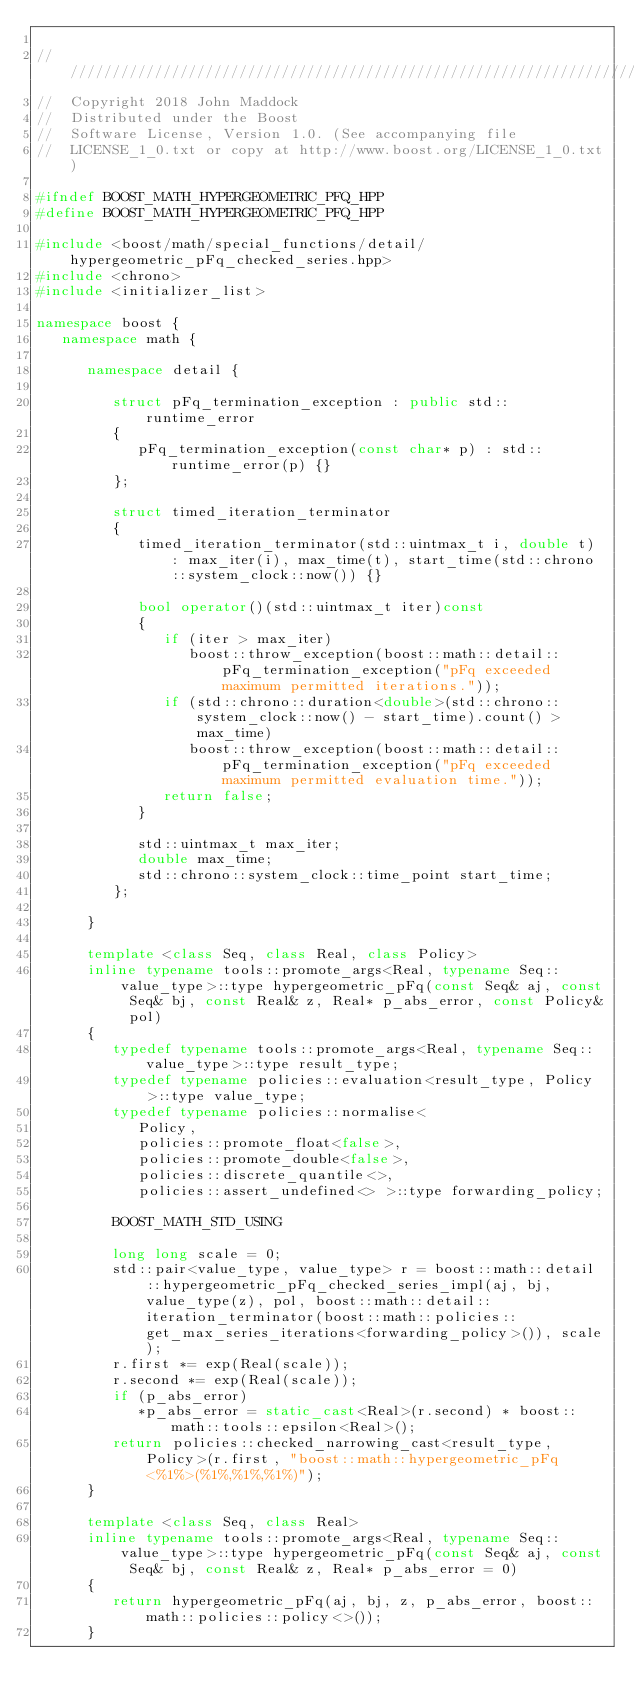Convert code to text. <code><loc_0><loc_0><loc_500><loc_500><_C++_>
///////////////////////////////////////////////////////////////////////////////
//  Copyright 2018 John Maddock
//  Distributed under the Boost
//  Software License, Version 1.0. (See accompanying file
//  LICENSE_1_0.txt or copy at http://www.boost.org/LICENSE_1_0.txt)

#ifndef BOOST_MATH_HYPERGEOMETRIC_PFQ_HPP
#define BOOST_MATH_HYPERGEOMETRIC_PFQ_HPP

#include <boost/math/special_functions/detail/hypergeometric_pFq_checked_series.hpp>
#include <chrono>
#include <initializer_list>

namespace boost {
   namespace math {

      namespace detail {

         struct pFq_termination_exception : public std::runtime_error
         {
            pFq_termination_exception(const char* p) : std::runtime_error(p) {}
         };

         struct timed_iteration_terminator
         {
            timed_iteration_terminator(std::uintmax_t i, double t) : max_iter(i), max_time(t), start_time(std::chrono::system_clock::now()) {}

            bool operator()(std::uintmax_t iter)const
            {
               if (iter > max_iter)
                  boost::throw_exception(boost::math::detail::pFq_termination_exception("pFq exceeded maximum permitted iterations."));
               if (std::chrono::duration<double>(std::chrono::system_clock::now() - start_time).count() > max_time)
                  boost::throw_exception(boost::math::detail::pFq_termination_exception("pFq exceeded maximum permitted evaluation time."));
               return false;
            }

            std::uintmax_t max_iter;
            double max_time;
            std::chrono::system_clock::time_point start_time;
         };

      }

      template <class Seq, class Real, class Policy>
      inline typename tools::promote_args<Real, typename Seq::value_type>::type hypergeometric_pFq(const Seq& aj, const Seq& bj, const Real& z, Real* p_abs_error, const Policy& pol)
      {
         typedef typename tools::promote_args<Real, typename Seq::value_type>::type result_type;
         typedef typename policies::evaluation<result_type, Policy>::type value_type;
         typedef typename policies::normalise<
            Policy,
            policies::promote_float<false>,
            policies::promote_double<false>,
            policies::discrete_quantile<>,
            policies::assert_undefined<> >::type forwarding_policy;

         BOOST_MATH_STD_USING

         long long scale = 0;
         std::pair<value_type, value_type> r = boost::math::detail::hypergeometric_pFq_checked_series_impl(aj, bj, value_type(z), pol, boost::math::detail::iteration_terminator(boost::math::policies::get_max_series_iterations<forwarding_policy>()), scale);
         r.first *= exp(Real(scale));
         r.second *= exp(Real(scale));
         if (p_abs_error)
            *p_abs_error = static_cast<Real>(r.second) * boost::math::tools::epsilon<Real>();
         return policies::checked_narrowing_cast<result_type, Policy>(r.first, "boost::math::hypergeometric_pFq<%1%>(%1%,%1%,%1%)");
      }

      template <class Seq, class Real>
      inline typename tools::promote_args<Real, typename Seq::value_type>::type hypergeometric_pFq(const Seq& aj, const Seq& bj, const Real& z, Real* p_abs_error = 0)
      {
         return hypergeometric_pFq(aj, bj, z, p_abs_error, boost::math::policies::policy<>());
      }
</code> 